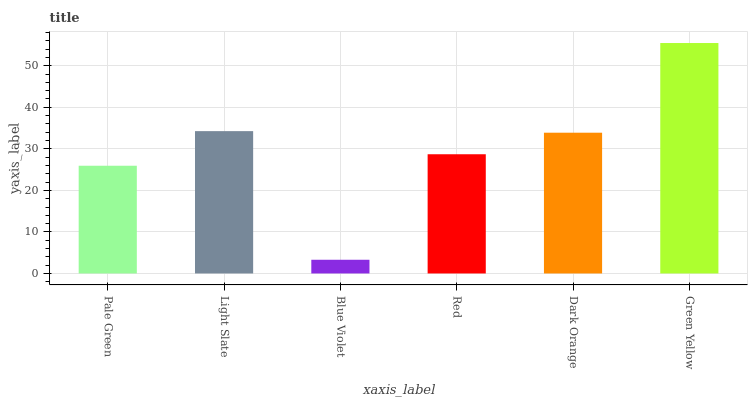Is Blue Violet the minimum?
Answer yes or no. Yes. Is Green Yellow the maximum?
Answer yes or no. Yes. Is Light Slate the minimum?
Answer yes or no. No. Is Light Slate the maximum?
Answer yes or no. No. Is Light Slate greater than Pale Green?
Answer yes or no. Yes. Is Pale Green less than Light Slate?
Answer yes or no. Yes. Is Pale Green greater than Light Slate?
Answer yes or no. No. Is Light Slate less than Pale Green?
Answer yes or no. No. Is Dark Orange the high median?
Answer yes or no. Yes. Is Red the low median?
Answer yes or no. Yes. Is Red the high median?
Answer yes or no. No. Is Green Yellow the low median?
Answer yes or no. No. 